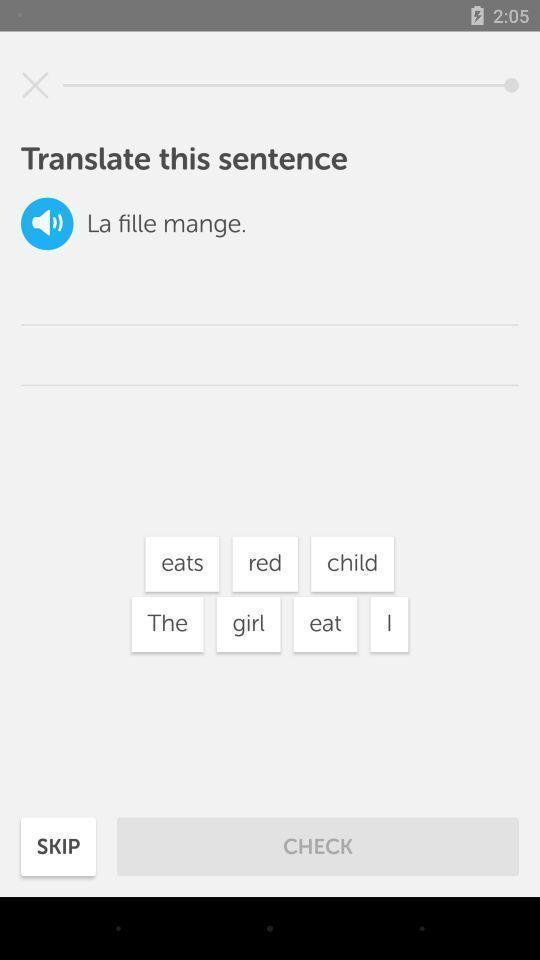Tell me what you see in this picture. Screen showing translation of sentence. 